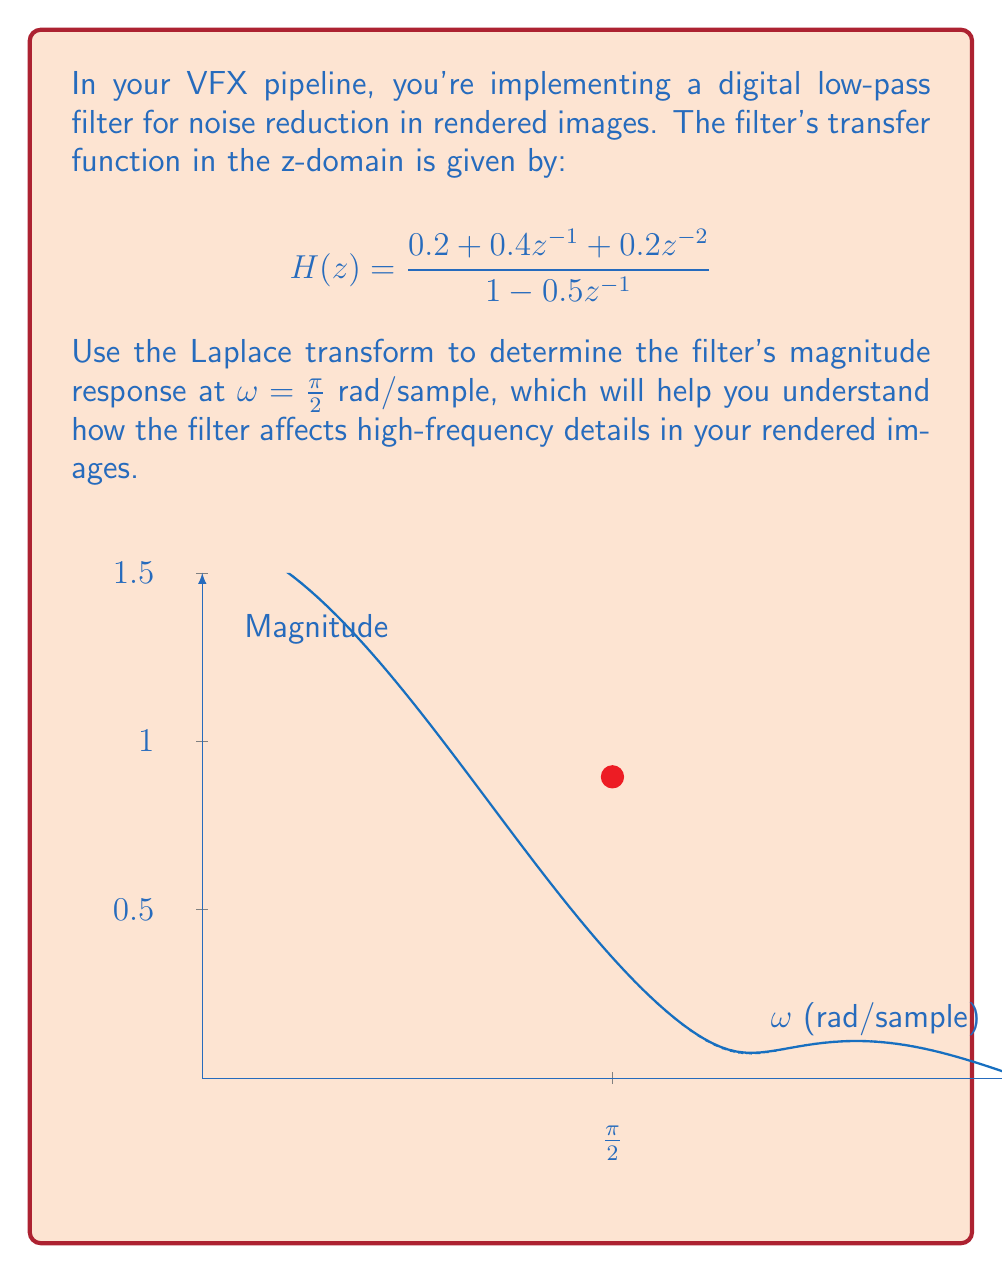Teach me how to tackle this problem. Let's approach this step-by-step:

1) First, we need to convert the z-domain transfer function to the frequency domain. We can do this by substituting $z = e^{j\omega}$:

   $$H(e^{j\omega}) = \frac{0.2 + 0.4e^{-j\omega} + 0.2e^{-2j\omega}}{1 - 0.5e^{-j\omega}}$$

2) The magnitude response is given by the absolute value of this complex function:

   $$|H(e^{j\omega})| = \left|\frac{0.2 + 0.4e^{-j\omega} + 0.2e^{-2j\omega}}{1 - 0.5e^{-j\omega}}\right|$$

3) Using Euler's formula, $e^{-j\omega} = \cos\omega - j\sin\omega$, we can rewrite the numerator and denominator:

   Numerator: $0.2 + 0.4(\cos\omega - j\sin\omega) + 0.2(\cos2\omega - j\sin2\omega)$
   $= (0.2 + 0.4\cos\omega + 0.2\cos2\omega) - j(0.4\sin\omega + 0.2\sin2\omega)$

   Denominator: $1 - 0.5(\cos\omega - j\sin\omega) = (1 - 0.5\cos\omega) + j0.5\sin\omega$

4) The magnitude is the square root of the sum of squares of real and imaginary parts:

   $$|H(e^{j\omega})| = \sqrt{\frac{(0.2 + 0.4\cos\omega + 0.2\cos2\omega)^2 + (0.4\sin\omega + 0.2\sin2\omega)^2}{(1 - 0.5\cos\omega)^2 + (0.5\sin\omega)^2}}$$

5) Now, we need to evaluate this at ω = π/2:

   $$|H(e^{j\pi/2})| = \sqrt{\frac{(0.2 + 0.4\cos(\pi/2) + 0.2\cos(\pi))^2 + (0.4\sin(\pi/2) + 0.2\sin(\pi))^2}{(1 - 0.5\cos(\pi/2))^2 + (0.5\sin(\pi/2))^2}}$$

6) Simplify:
   $\cos(\pi/2) = 0$, $\cos(\pi) = -1$, $\sin(\pi/2) = 1$, $\sin(\pi) = 0$

   $$|H(e^{j\pi/2})| = \sqrt{\frac{(0.2 + 0 - 0.2)^2 + (0.4 + 0)^2}{(1 - 0)^2 + (0.5)^2}} = \sqrt{\frac{0^2 + 0.4^2}{1^2 + 0.5^2}}$$

7) Calculate the final result:

   $$|H(e^{j\pi/2})| = \sqrt{\frac{0.16}{1.25}} = \frac{0.4}{\sqrt{1.25}} \approx 0.3578$$

This value represents how much the filter attenuates frequencies at ω = π/2 rad/sample.
Answer: $|H(e^{j\pi/2})| = \frac{0.4}{\sqrt{1.25}} \approx 0.3578$ 